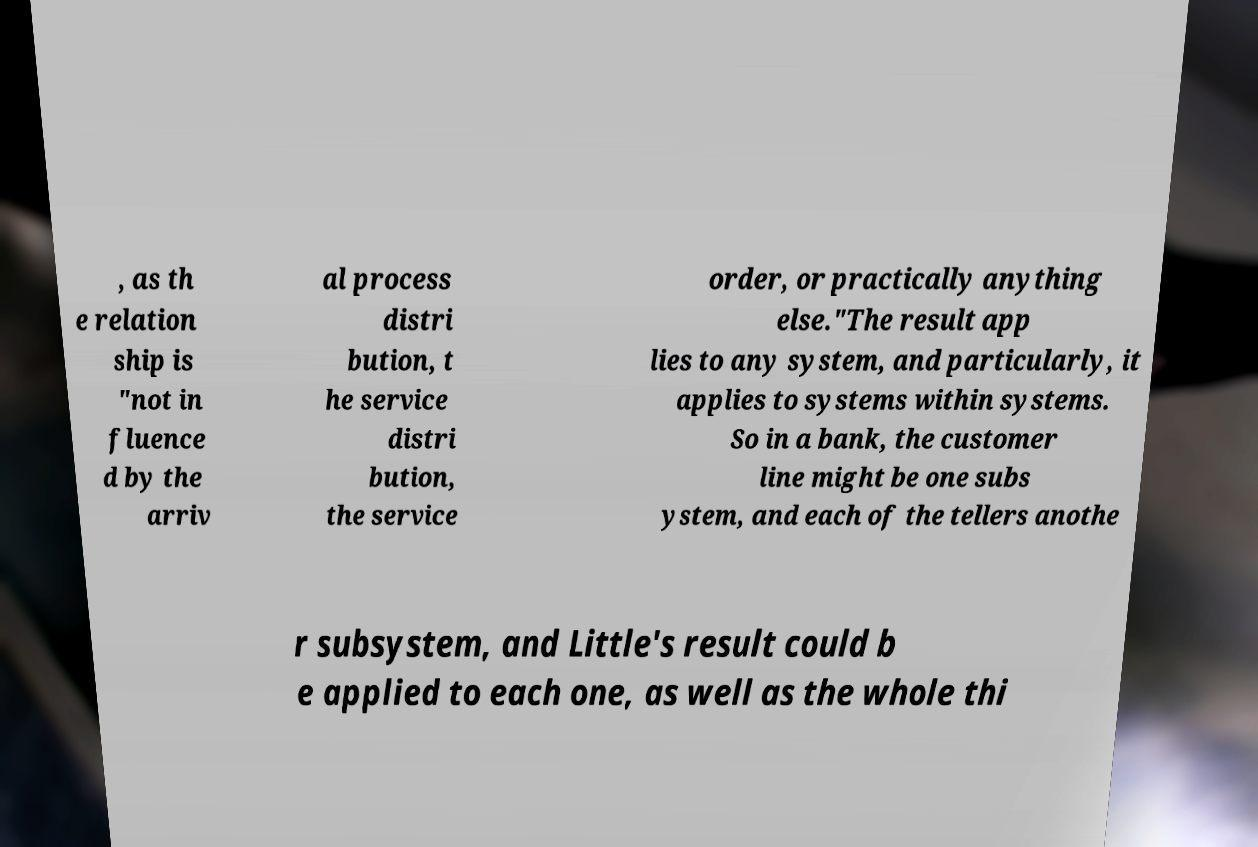There's text embedded in this image that I need extracted. Can you transcribe it verbatim? , as th e relation ship is "not in fluence d by the arriv al process distri bution, t he service distri bution, the service order, or practically anything else."The result app lies to any system, and particularly, it applies to systems within systems. So in a bank, the customer line might be one subs ystem, and each of the tellers anothe r subsystem, and Little's result could b e applied to each one, as well as the whole thi 